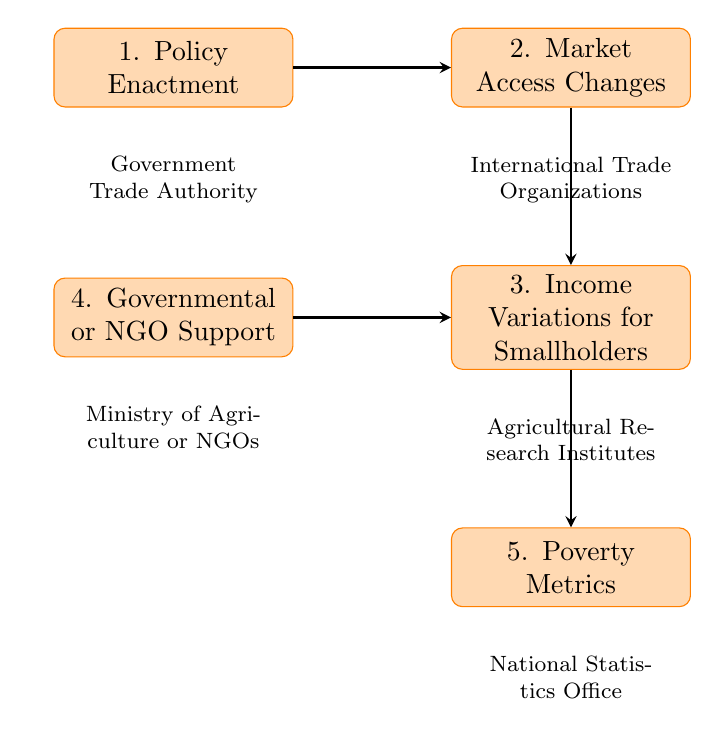What is the first step in the flow chart? The first node in the flow chart is labeled "Policy Enactment," which represents the initial action taken in the process.
Answer: Policy Enactment How many nodes are in the diagram? The diagram contains five distinct nodes, each representing a step or component in the assessment process.
Answer: 5 Which entity is associated with "Market Access Changes"? The node "Market Access Changes" is connected to the entity "International Trade Organizations," as indicated in the diagram.
Answer: International Trade Organizations What influences the "Income Variations for Smallholders"? "Income Variations for Smallholders" is influenced by two nodes: "Market Access Changes" and "Governmental or NGO Support," as the arrows point to it from these two nodes.
Answer: Market Access Changes, Governmental or NGO Support Which node leads to "Poverty Metrics"? The arrow connected to "Poverty Metrics" originates from the node "Income Variations for Smallholders," indicating a direct influence on the poverty metrics analysis.
Answer: Income Variations for Smallholders What type of support is mentioned in the diagram? The node labeled "Governmental or NGO Support" specifies types of support such as subsidies, grants, and training for smallholder farmers.
Answer: Subsidies, grants, and training Which organization is responsible for the analysis of poverty metrics? "Poverty Metrics" is analyzed by the "National Statistics Office," as indicated in the flow chart.
Answer: National Statistics Office What is the relationship between "Policy Enactment" and "Market Access Changes"? The relationship shows a directional flow where "Policy Enactment" directly leads to "Market Access Changes," indicating that enacted policies cause changes in market access.
Answer: Direct influence How does "Governmental or NGO Support" affect income for smallholders? "Governmental or NGO Support" contributes to "Income Variations for Smallholders" as it provides needed resources that can enhance their income, indicated by the arrow between these nodes.
Answer: Enhances income 